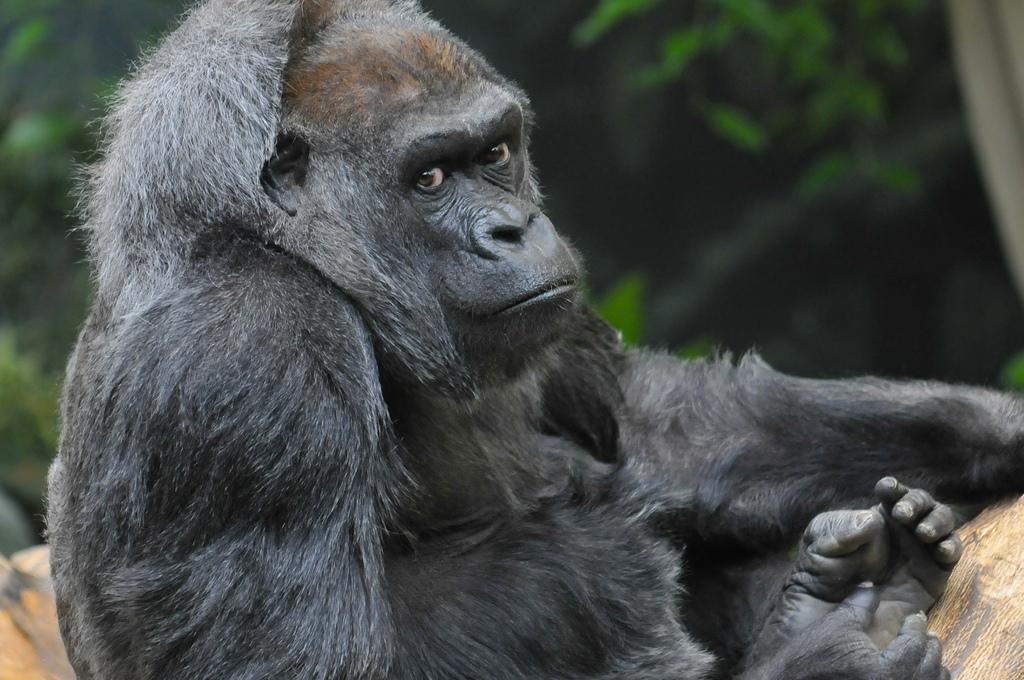What type of animal is in the image? There is a black color monkey in the image. What can be seen in the background of the image? There are trees in the background of the image. What type of bird is the crook trying to catch in the image? There is no bird or crook present in the image; it only features a black color monkey and trees in the background. 